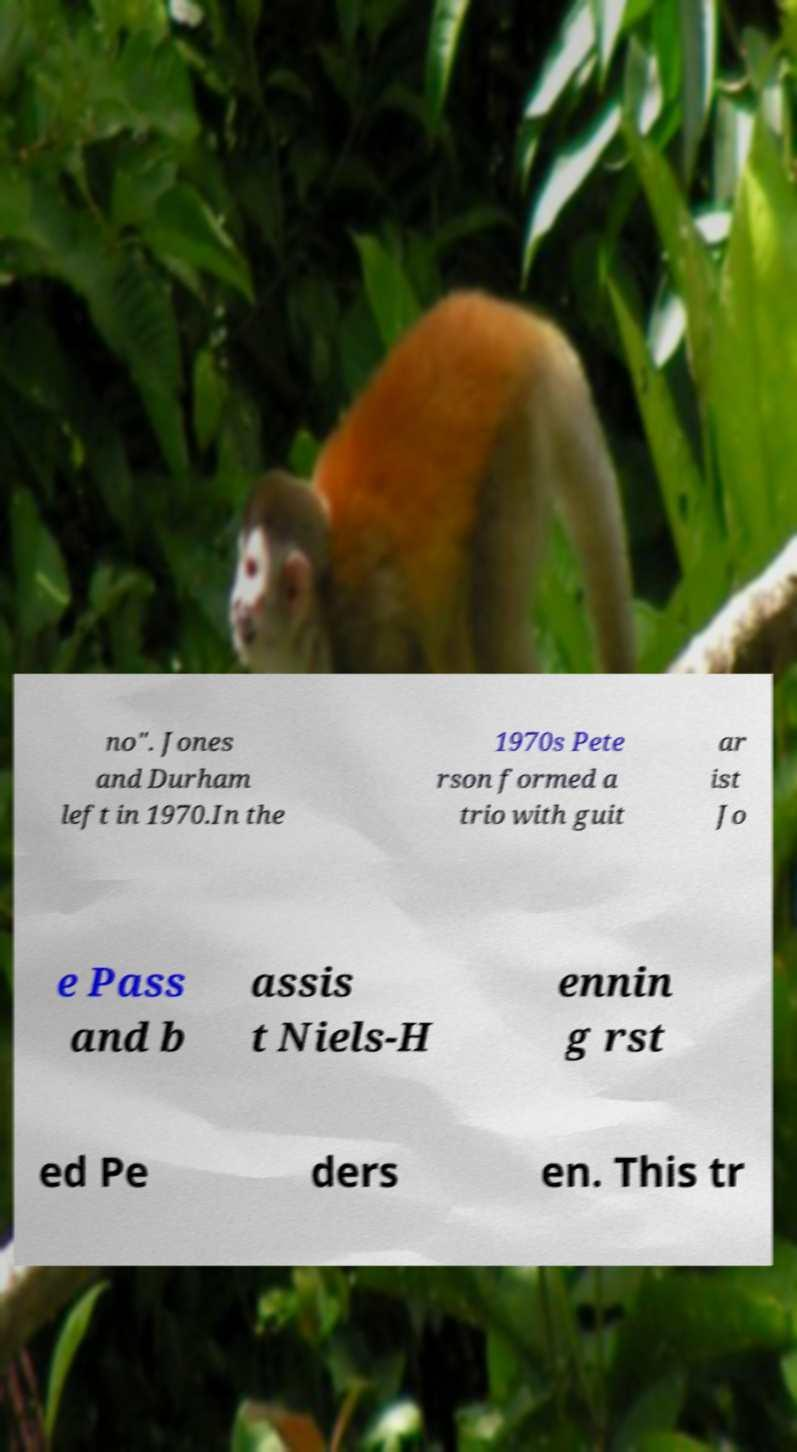Please read and relay the text visible in this image. What does it say? no". Jones and Durham left in 1970.In the 1970s Pete rson formed a trio with guit ar ist Jo e Pass and b assis t Niels-H ennin g rst ed Pe ders en. This tr 